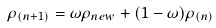<formula> <loc_0><loc_0><loc_500><loc_500>\rho _ { ( n + 1 ) } = \omega \rho _ { n e w } + ( 1 - \omega ) \rho _ { ( n ) }</formula> 